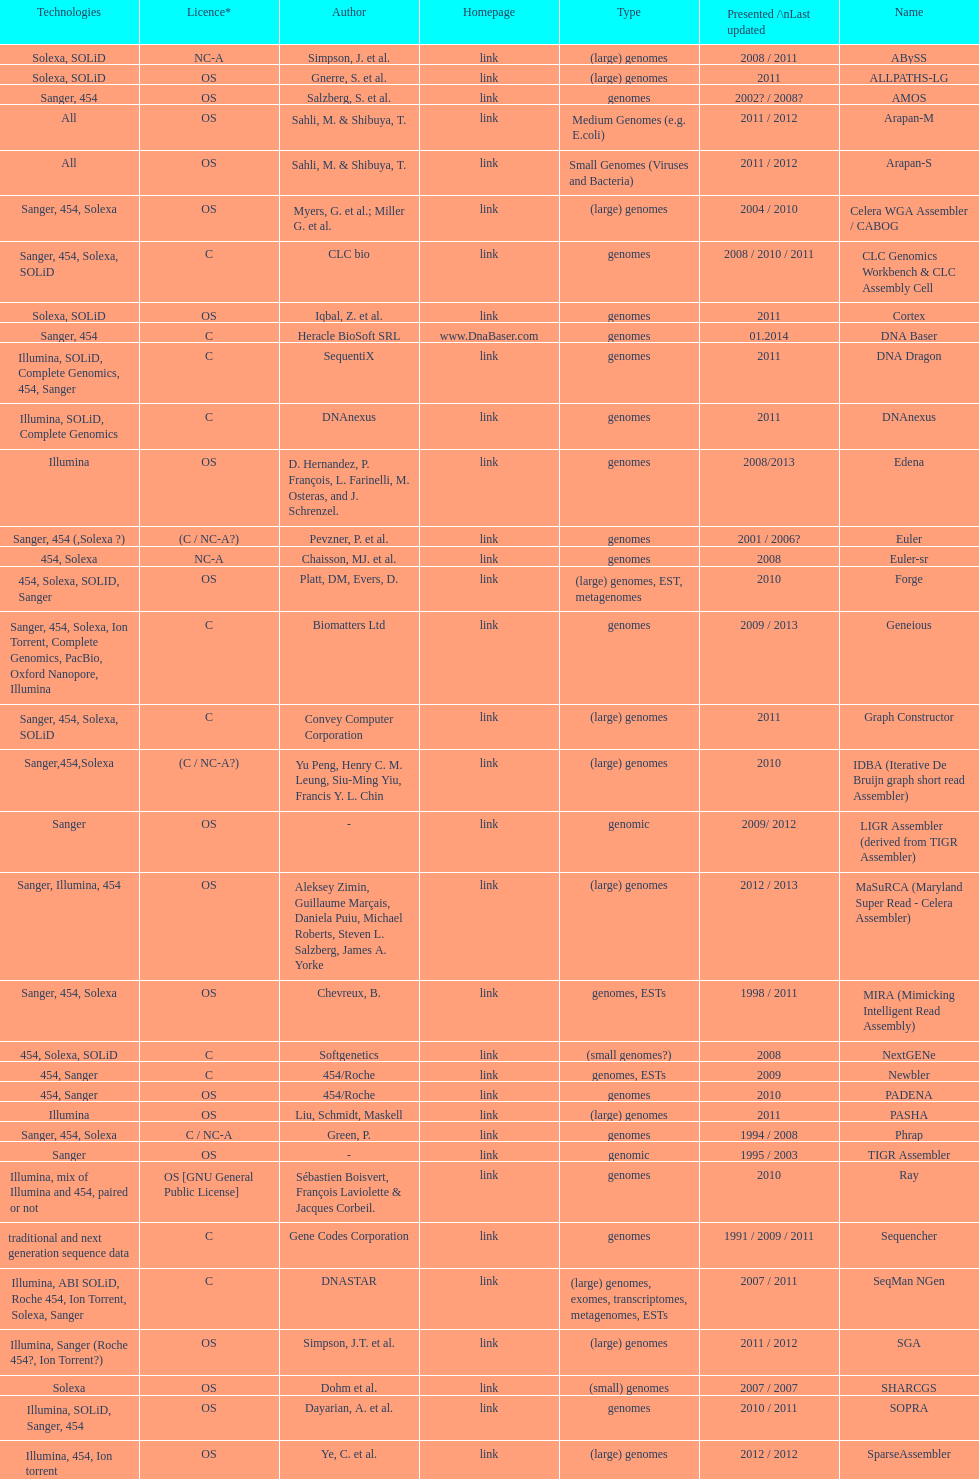How many are listed as "all" technologies? 2. 